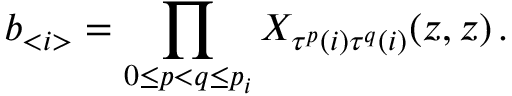<formula> <loc_0><loc_0><loc_500><loc_500>b _ { < i > } = \prod _ { 0 \leq p < q \leq p _ { i } } X _ { \tau ^ { p } ( i ) \tau ^ { q } ( i ) } ( z , z ) \, .</formula> 